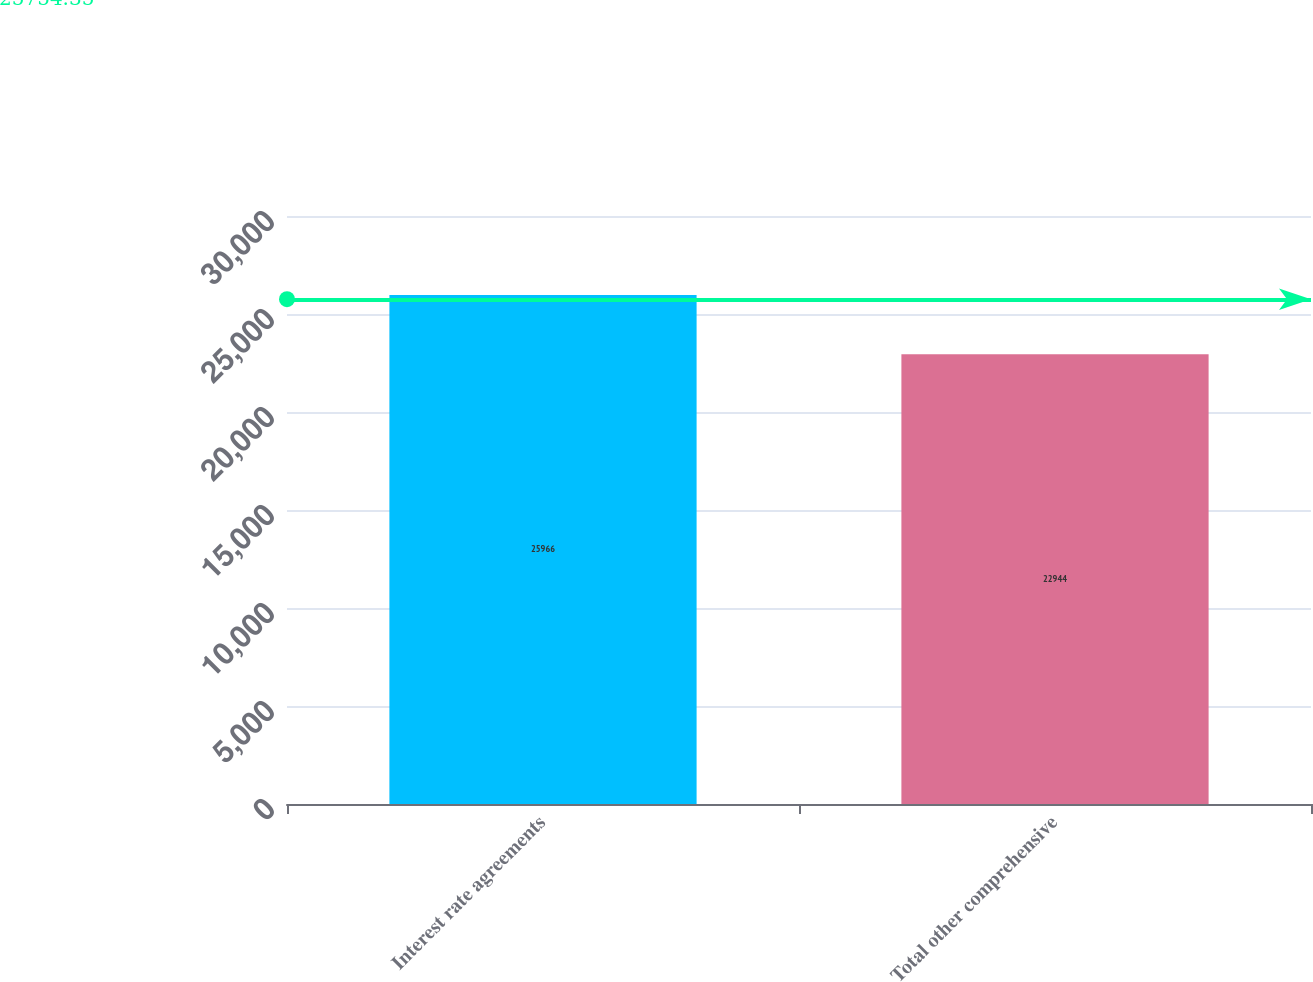Convert chart. <chart><loc_0><loc_0><loc_500><loc_500><bar_chart><fcel>Interest rate agreements<fcel>Total other comprehensive<nl><fcel>25966<fcel>22944<nl></chart> 